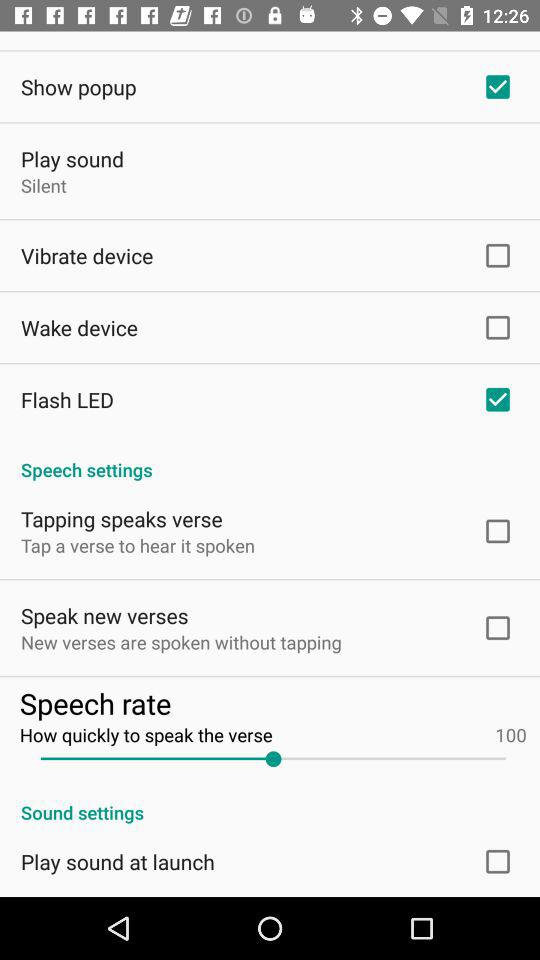What is the status of the "Show popup"? The status is "on". 